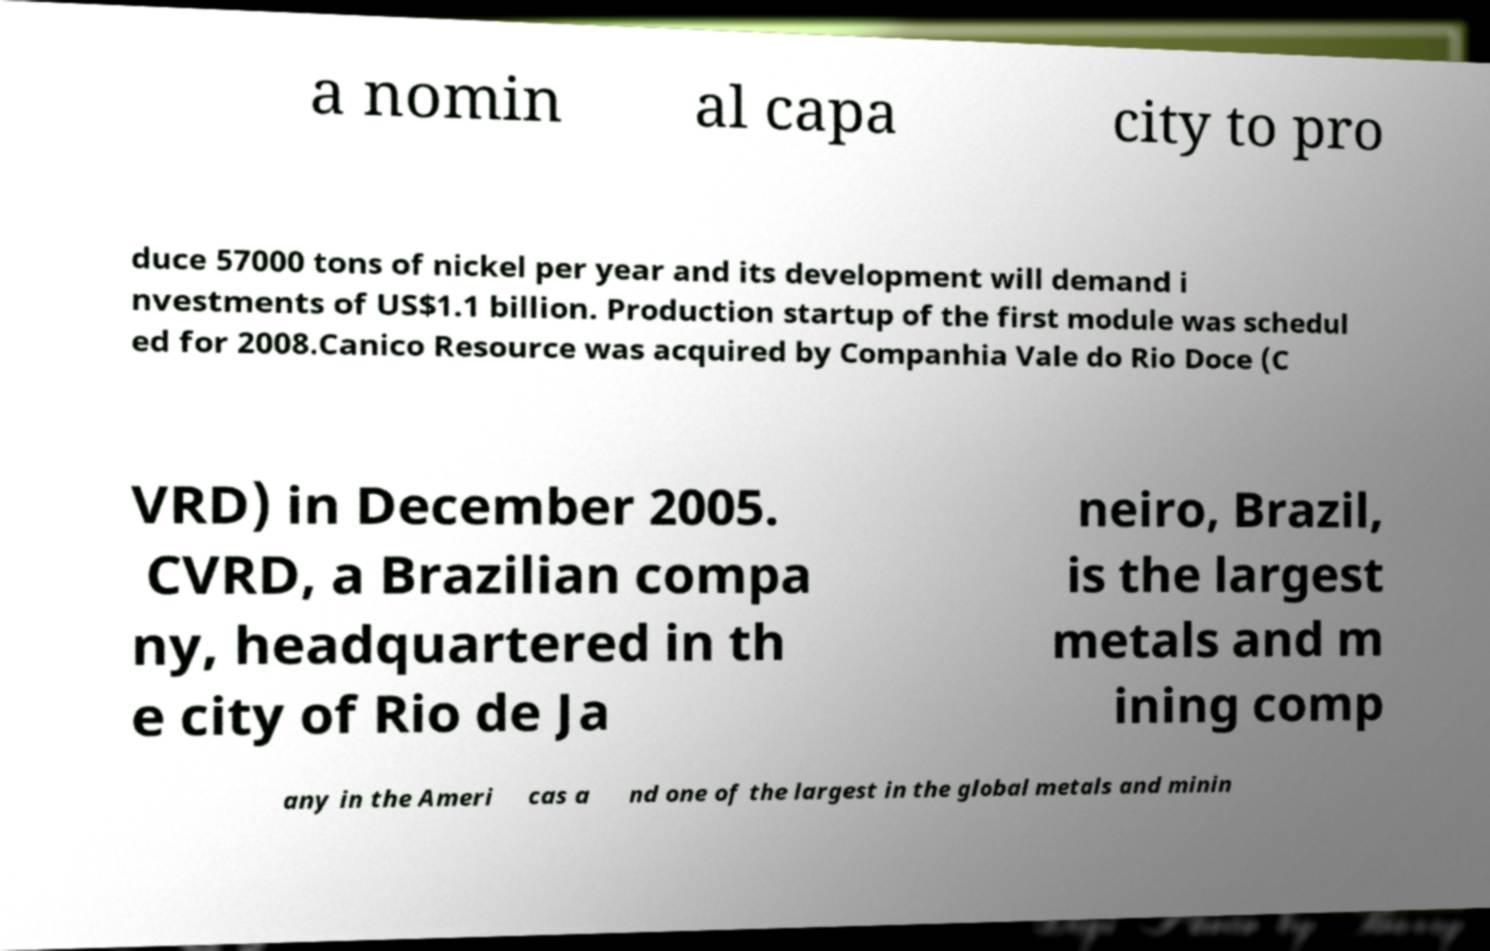For documentation purposes, I need the text within this image transcribed. Could you provide that? a nomin al capa city to pro duce 57000 tons of nickel per year and its development will demand i nvestments of US$1.1 billion. Production startup of the first module was schedul ed for 2008.Canico Resource was acquired by Companhia Vale do Rio Doce (C VRD) in December 2005. CVRD, a Brazilian compa ny, headquartered in th e city of Rio de Ja neiro, Brazil, is the largest metals and m ining comp any in the Ameri cas a nd one of the largest in the global metals and minin 